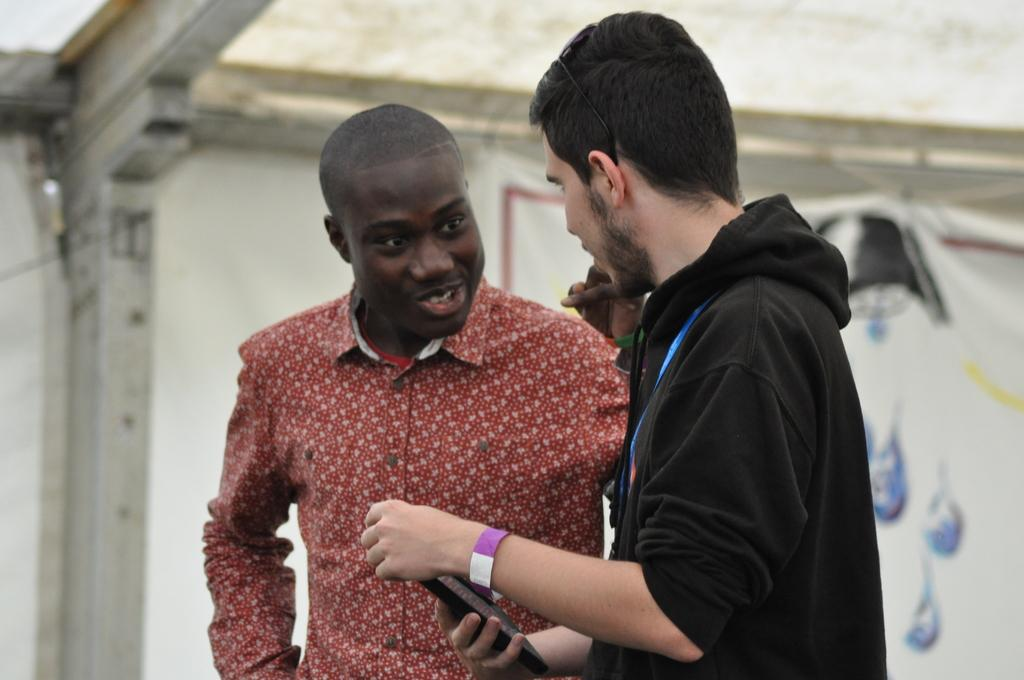How many people are in the image? There are two men in the image. What is one of the men wearing? One of the men is wearing a black color hoodie. What can be seen in the background of the image? There is a wall in the background of the image. What letter is the man in the hoodie holding in the image? There is no letter present in the image; the man in the hoodie is not holding anything. 